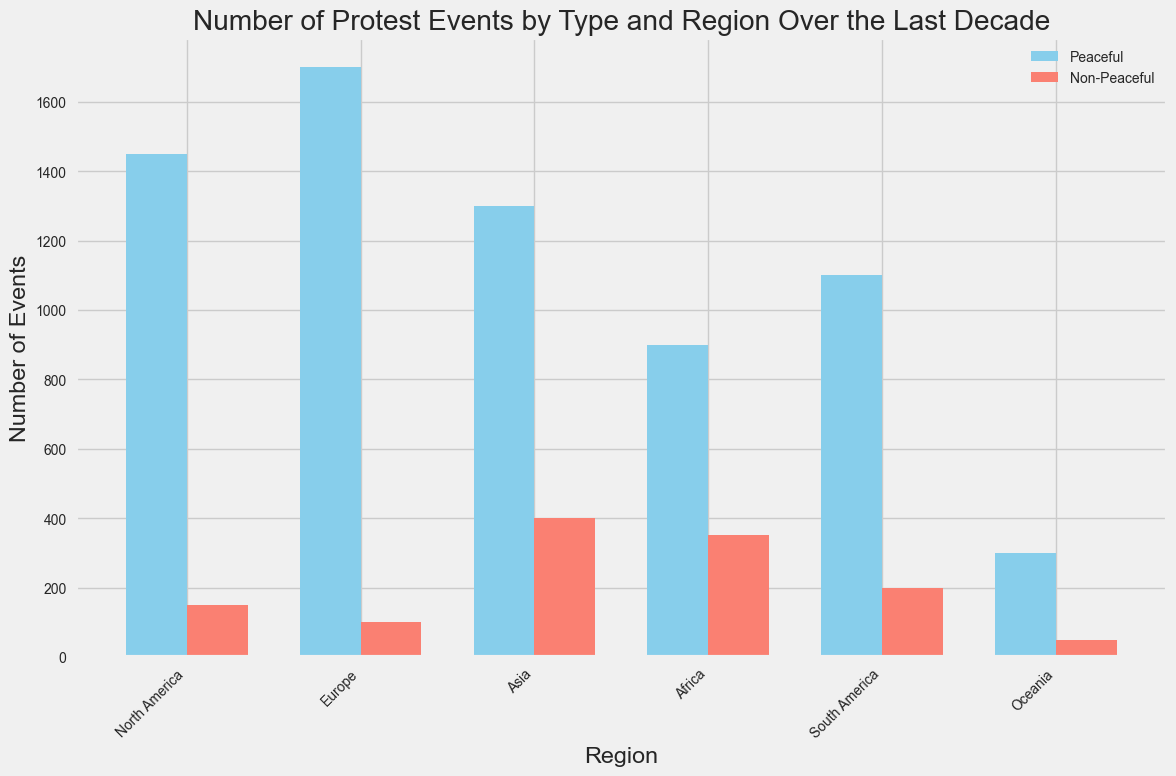Which region has the highest number of peaceful protests? To find this, look for the tallest blue bar representing 'Peaceful' events. The tallest blue bar is in Europe.
Answer: Europe Which region has the smallest difference between peaceful and non-peaceful protests? Calculate the difference for each region and identify the smallest one. North America has a difference of 1300 (1450-150), Europe has 1600 (1700-100), Asia has 900 (1300-400), Africa has 550 (900-350), South America has 900 (1100-200), and Oceania has 250 (300-50). The smallest is Oceania with a difference of 250.
Answer: Oceania Which type of protests (Peaceful or Non-Peaceful) are more prevalent in Asia? Compare the heights of the blue and red bars for Asia. The blue bar (Peaceful) is taller than the red bar (Non-Peaceful), indicating that peaceful protests are more prevalent.
Answer: Peaceful In which region is the number of non-peaceful protests the highest? Look for the tallest red bar representing 'Non-Peaceful' events. The tallest red bar is in Asia.
Answer: Asia What is the combined number of protests (both peaceful and non-peaceful) in Africa? Add the values of both bars for Africa: 900 (peaceful) + 350 (non-peaceful) = 1250.
Answer: 1250 How does South America rank in terms of peaceful protests compared to other regions? Compare the height of the blue bar in South America with those in other regions. Europe > North America > Asia > South America > Africa > Oceania. South America is the fourth highest.
Answer: Fourth Which region has the greatest proportion of non-peaceful protests to total protests? Calculate the proportion for each region and compare. Proportions are: North America = 150/(1450+150) = 0.094, Europe = 100/(1700+100) = 0.056, Asia = 400/(1300+400) = 0.235, Africa = 350/(900+350) = 0.28, South America = 200/(1100+200) = 0.154, Oceania = 50/(300+50) = 0.143. Africa has the highest proportion (0.28).
Answer: Africa What is the ratio of peaceful protests to non-peaceful protests in North America? Divide the number of peaceful protests by the number of non-peaceful protests in North America: 1450/150 = 9.67.
Answer: 9.67 In which two regions are the numbers of non-peaceful protests roughly equal? Compare the heights of the red bars across regions. North America (150) and Oceania (50) are similar. South America (200) is closest to Oceania’s 50.
Answer: South America and Oceania 